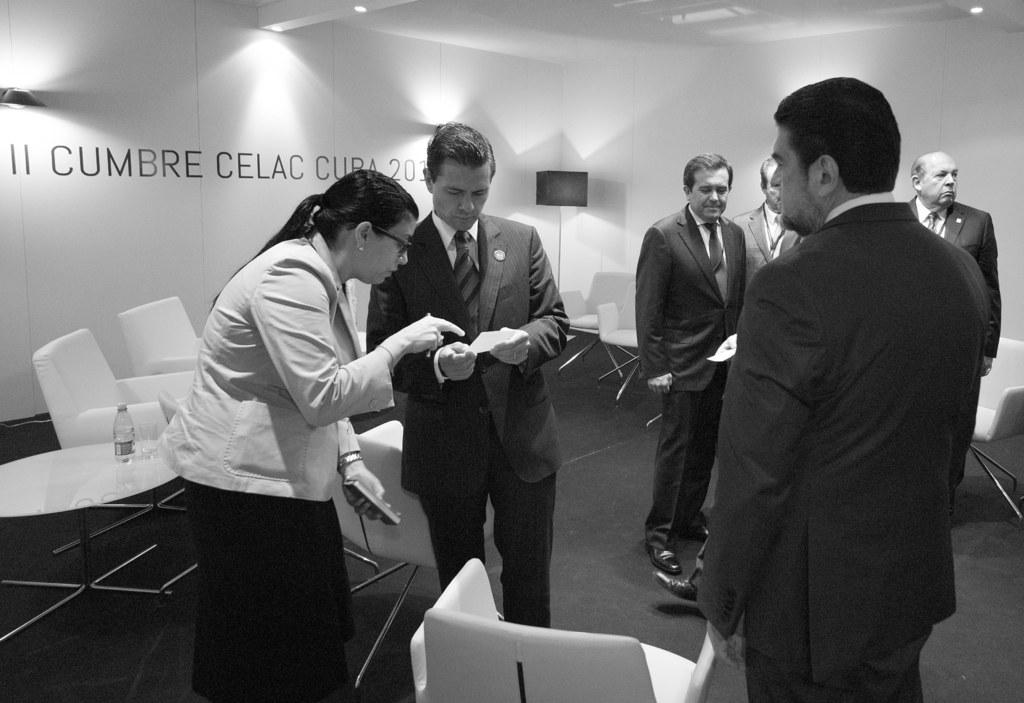What are the persons in the image wearing? The persons in the image are wearing suits. What are the persons doing in the image? The persons are standing. What objects are located beside the standing persons? There are chairs beside the standing persons. What can be seen on the wall in the background of the image? There is something written on the wall in the background of the image. What level of expertise does the beginner badge indicate in the image? There is no mention of a beginner badge or any badges in the image. 